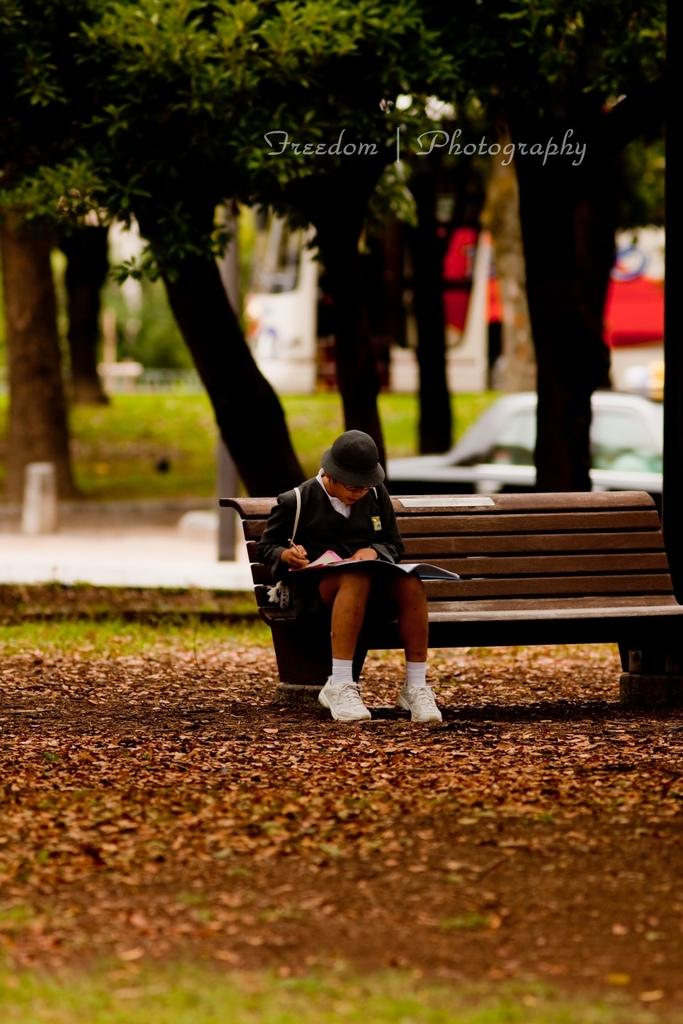What type of vegetation can be seen in the background of the image? There are trees in the background of the image. What else is visible in the background of the image? There is a vehicle in the background of the image. What is the ground surface like in the image? There is grass visible in the image. What is the person in the image doing? The person is sitting on a bench in the image. What is the person holding in their hand? The person is holding a pen in their hand. What object is present in the image that might be used for reading or learning? There is a book in the image. What additional detail can be observed on the ground in the image? Dried leaves are present in the image. How many spiders are crawling on the kettle in the image? There is no kettle or spiders present in the image. What type of creature can be seen grazing in the background of the image? There are no cows or any other grazing animals present in the image. 